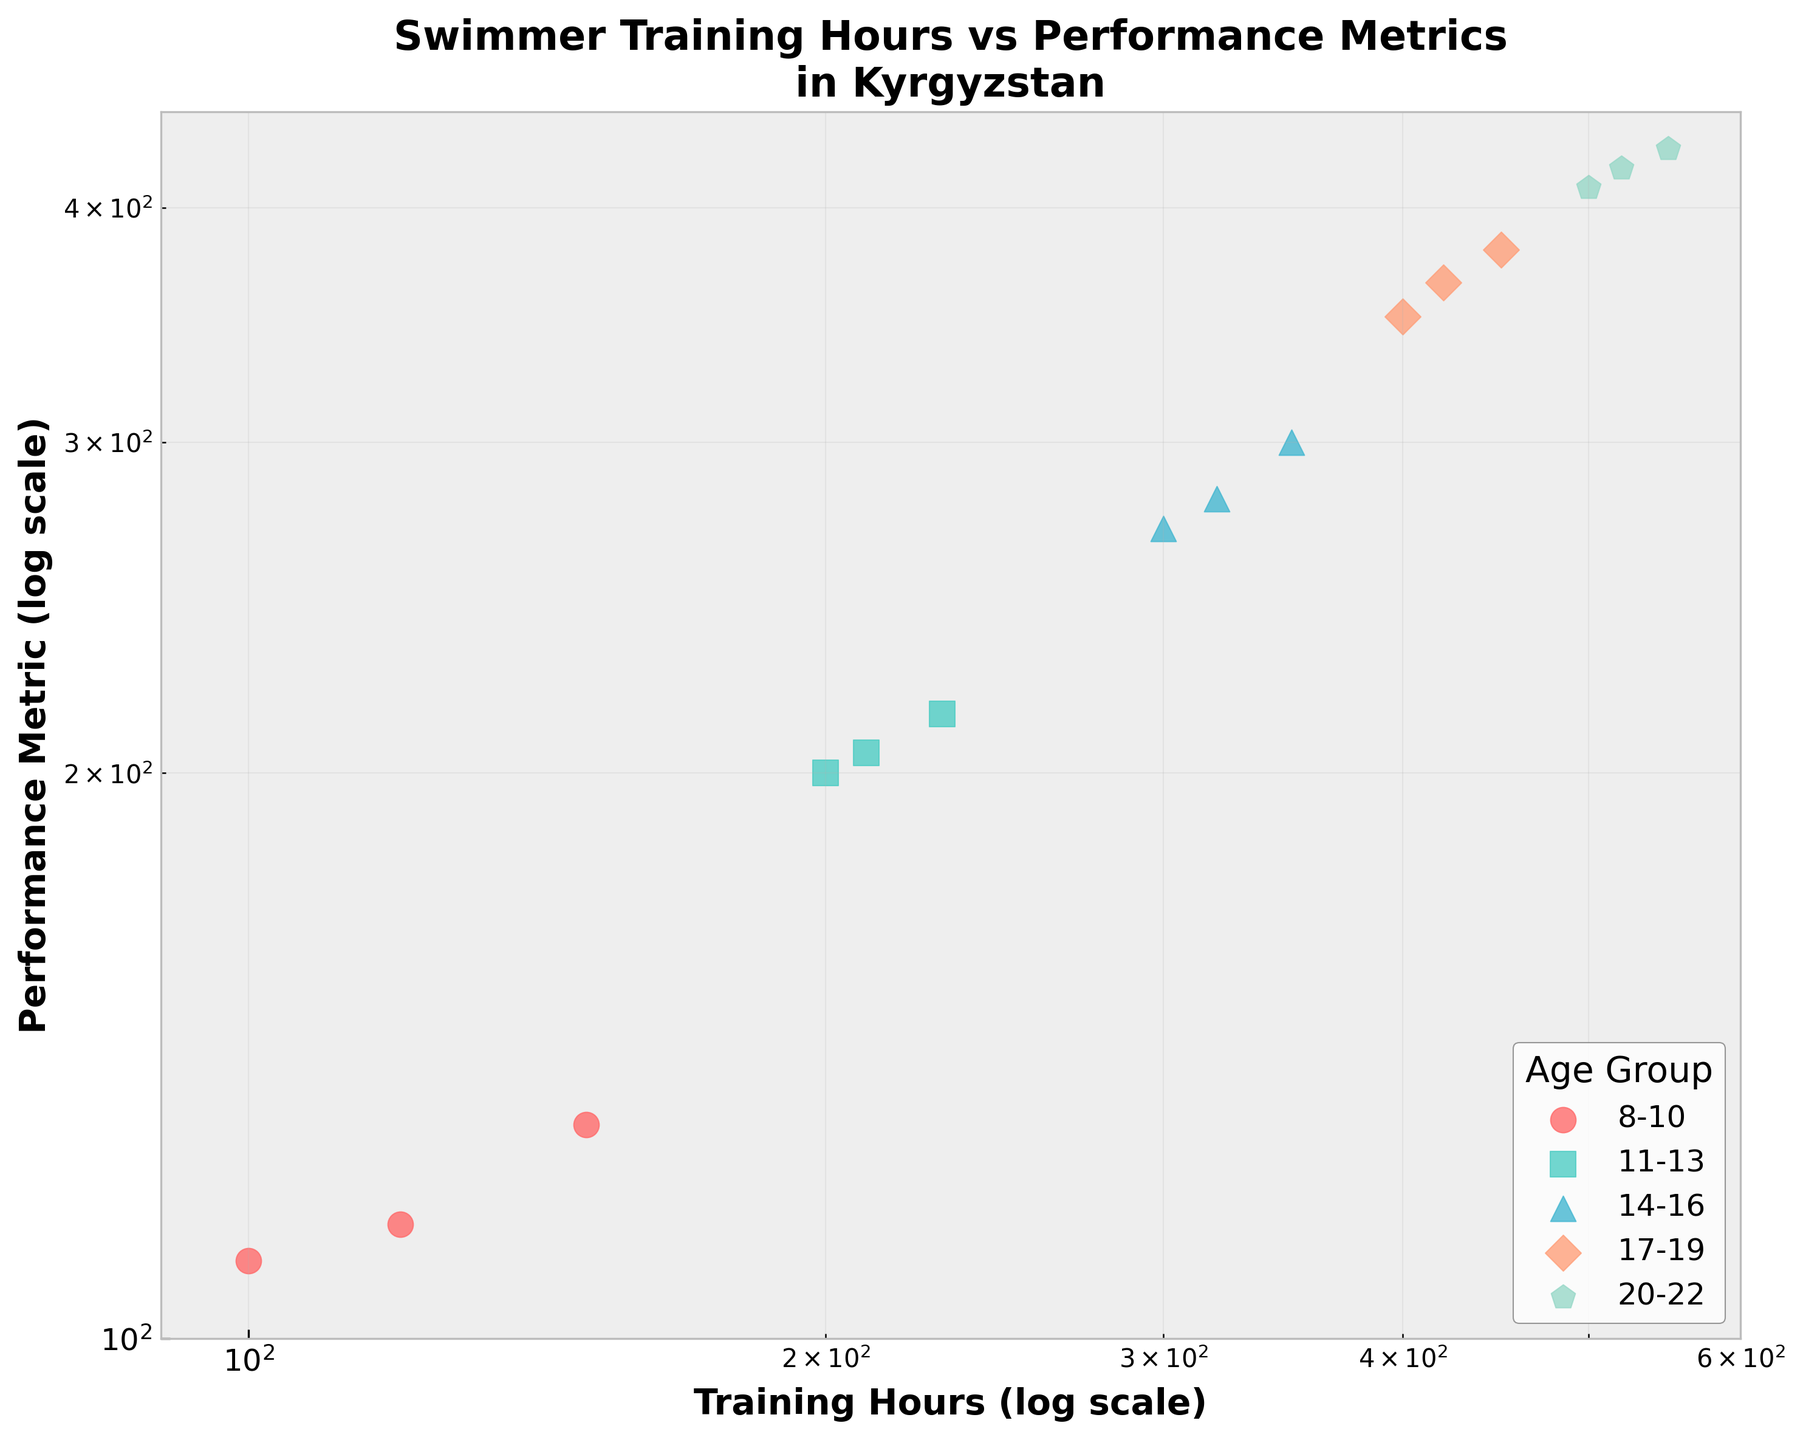What is the title of the scatter plot? The title can be found at the top of the graph. It reads "Swimmer Training Hours vs Performance Metrics in Kyrgyzstan".
Answer: Swimmer Training Hours vs Performance Metrics in Kyrgyzstan What age group has the highest training hours shown on the plot? By looking at the points on the x-axis, the age group with the highest training hours (450 and above) is the 20-22 age group, indicated by a distinct color and marker.
Answer: 20-22 Which axis represents training hours and which represents performance metrics? The x-axis represents training hours and the y-axis represents performance metrics, as labeled on the graph.
Answer: x-axis: Training Hours,  y-axis: Performance Metric How many data points are plotted for the age group 14-16? Each age group is represented by a unique color and marker. Counting the points for the 14-16 age group, we see there are 3 points.
Answer: 3 Which age group appears to have the most tightly clustered performance metrics? By examining the scatter plot, the 11-13 age group has the data points closest together in terms of performance metrics on the y-axis.
Answer: 11-13 How does the relationship between training hours and performance metrics change as age increases? As age increases, the training hours and performance metrics both increase, shown by the data points shifting to the upper-right corner of the log-log plot for older age groups.
Answer: Increases for both Is there any age group where an increase in training hours does not correspond to a proportional increase in performance metrics? By comparing the spread of data points, there is a slight deviation in proportional increase for the 8-10 age group where performance metrics do not increase as sharply with training hours compared to other groups.
Answer: 8-10 Which age group has the lowest range of training hours? By looking at the spread along the x-axis, the 8-10 age group shows the least variation in training hours, ranging from 100 to 150.
Answer: 8-10 What is the performance metric value for the data point with the highest training hours? The point with the highest training hours is in the 20-22 age group at 550 hours. The corresponding performance metric value can be seen at approximately 430.
Answer: 430 